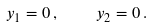Convert formula to latex. <formula><loc_0><loc_0><loc_500><loc_500>y _ { 1 } = 0 \, , \quad y _ { 2 } = 0 \, .</formula> 